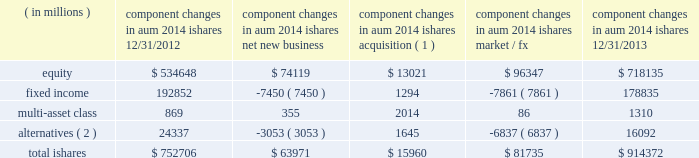The second largest closed-end fund manager and a top- ten manager by aum and 2013 net flows of long-term open-end mutual funds1 .
In 2013 , we were also the leading manager by net flows for long-dated fixed income mutual funds1 .
2022 we have fully integrated our legacy retail and ishares retail distribution teams to create a unified client-facing presence .
As retail clients increasingly use blackrock 2019s capabilities in combination 2014 active , alternative and passive 2014 it is a strategic priority for blackrock to coherently deliver these capabilities through one integrated team .
2022 international retail long-term net inflows of $ 17.5 billion , representing 15% ( 15 % ) organic growth , were positive across major regions and diversified across asset classes .
Equity net inflows of $ 6.4 billion were driven by strong demand for our top-performing european equities franchise as investor risk appetite for the sector improved .
Multi-asset class and fixed income products each generated net inflows of $ 4.8 billion , as investors looked to manage duration and volatility in their portfolios .
In 2013 , we were ranked as the third largest cross border fund provider2 .
In the united kingdom , we ranked among the five largest fund managers2 .
Ishares .
Alternatives ( 2 ) 24337 ( 3053 ) 1645 ( 6837 ) 16092 total ishares $ 752706 $ 63971 $ 15960 $ 81735 $ 914372 ( 1 ) amounts represent $ 16.0 billion of aum acquired in the credit suisse etf acquisition in july 2013 .
( 2 ) amounts include commodity ishares .
Ishares is the leading etf provider in the world , with $ 914.4 billion of aum at december 31 , 2013 , and was the top asset gatherer globally in 20133 with $ 64.0 billion of net inflows for an organic growth rate of 8% ( 8 % ) .
Equity net inflows of $ 74.1 billion were driven by flows into funds with broad developed market exposures , partially offset by outflows from emerging markets products .
Ishares fixed income experienced net outflows of $ 7.5 billion , as the continued low interest rate environment led many liquidity-oriented investors to sell long-duration assets , which made up the majority of the ishares fixed income suite .
In 2013 , we launched several funds to meet demand from clients seeking protection in a rising interest rate environment by offering an expanded product set that includes four new u.s .
Funds , including short-duration versions of our flagship high yield and investment grade credit products , and short maturity and liquidity income funds .
Ishares alternatives had $ 3.1 billion of net outflows predominantly out of commodities .
Ishares represented 23% ( 23 % ) of long-term aum at december 31 , 2013 and 35% ( 35 % ) of long-term base fees for ishares offers the most diverse product set in the industry with 703 etfs at year-end 2013 , and serves the broadest client base , covering more than 25 countries on five continents .
During 2013 , ishares continued its dual commitment to innovation and responsible product structuring by introducing 42 new etfs , acquiring credit suisse 2019s 58 etfs in europe and entering into a critical new strategic alliance with fidelity investments to deliver fidelity 2019s more than 10 million clients increased access to ishares products , tools and support .
Our alliance with fidelity investments and a successful full first year for the core series have deeply expanded our presence and offerings among buy-and-hold investors .
Our broad product range offers investors a precise , transparent and low-cost way to tap market returns and gain access to a full range of asset classes and global markets that have been difficult or expensive for many investors to access until now , as well as the liquidity required to make adjustments to their exposures quickly and cost-efficiently .
2022 u.s .
Ishares aum ended at $ 655.6 billion with $ 41.4 billion of net inflows driven by strong demand for developed markets equities and short-duration fixed income .
During the fourth quarter of 2012 , we debuted the core series in the united states , designed to provide the essential building blocks for buy-and-hold investors to use in constructing the core of their portfolio .
The core series demonstrated solid results in its first full year , raising $ 20.0 billion in net inflows , primarily in u.s .
Equities .
In the united states , ishares maintained its position as the largest etf provider , with 39% ( 39 % ) share of aum3 .
2022 international ishares aum ended at $ 258.8 billion with robust net new business of $ 22.6 billion led by demand for european and japanese equities , as well as a diverse range of fixed income products .
At year-end 2013 , ishares was the largest european etf provider with 48% ( 48 % ) of aum3 .
1 simfund 2 lipper feri 3 blackrock ; bloomberg .
Without the net new business led by demand for european and japanese equities , what was the value of international shares ? in billion $ ? 
Computations: (258.8 - 22.6)
Answer: 236.2. 